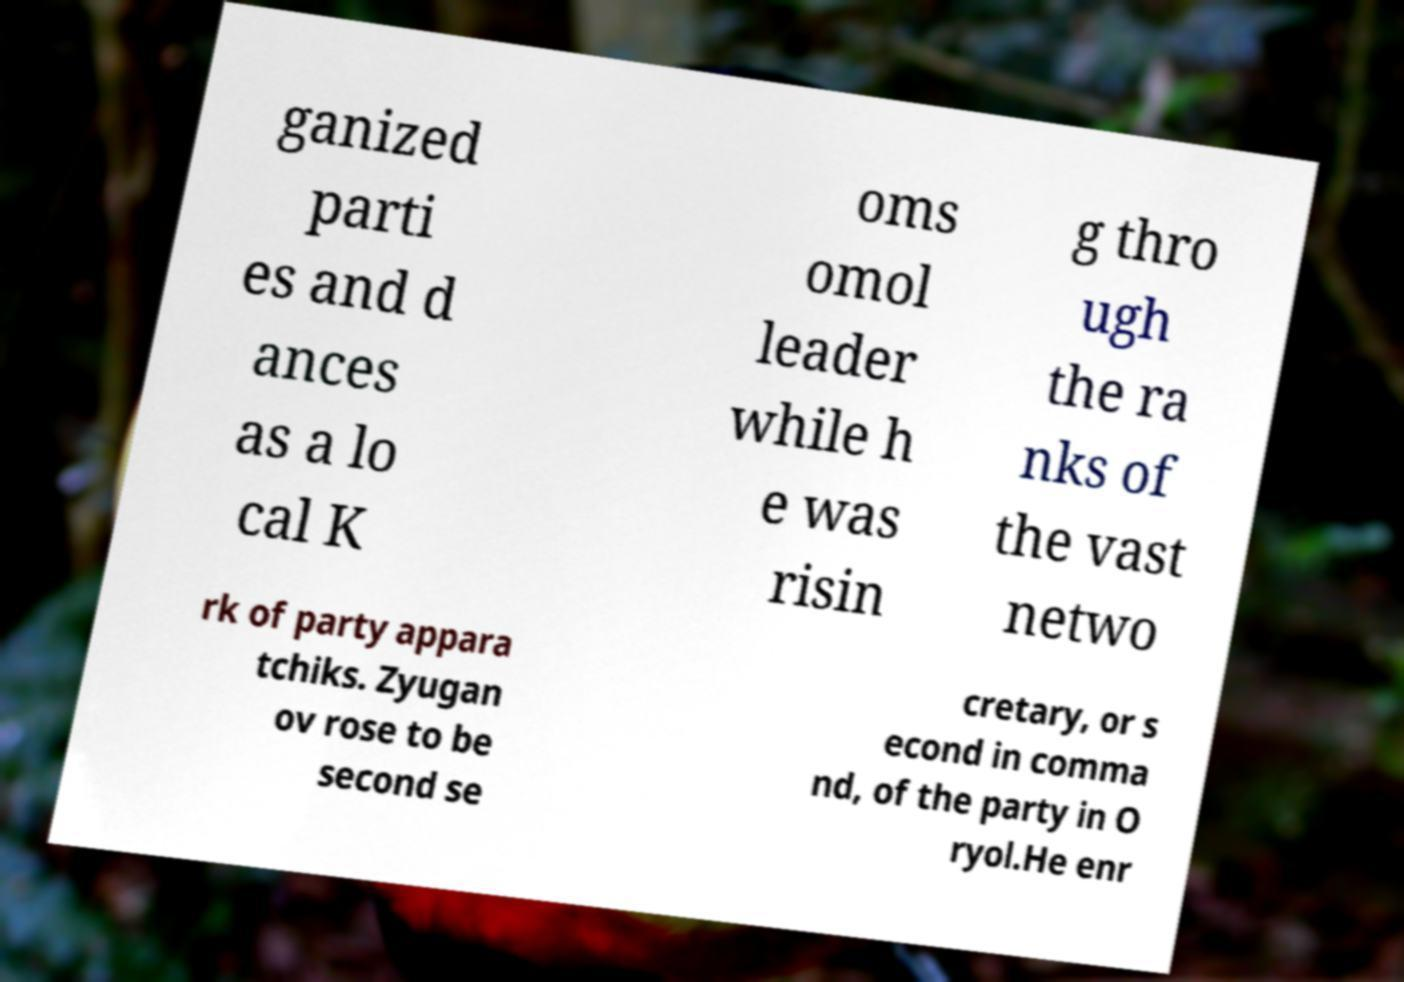Can you read and provide the text displayed in the image?This photo seems to have some interesting text. Can you extract and type it out for me? ganized parti es and d ances as a lo cal K oms omol leader while h e was risin g thro ugh the ra nks of the vast netwo rk of party appara tchiks. Zyugan ov rose to be second se cretary, or s econd in comma nd, of the party in O ryol.He enr 